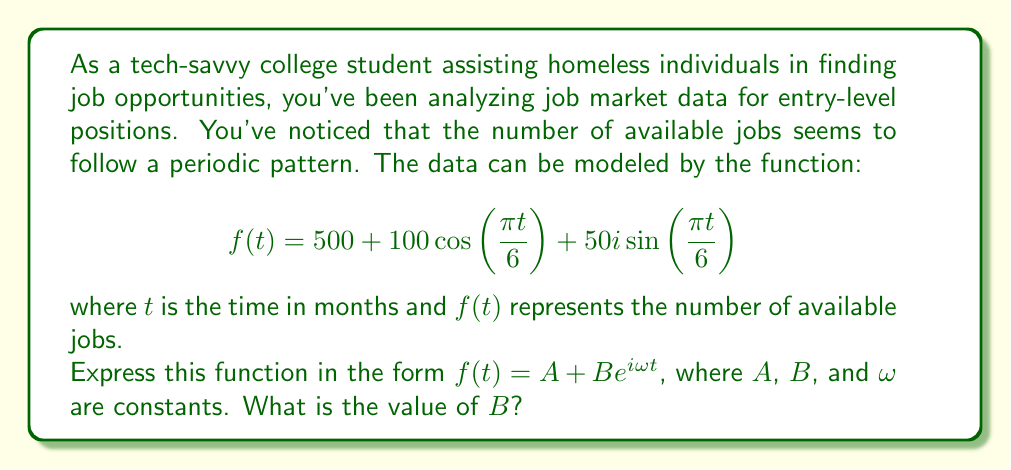Help me with this question. To express the given function in the form $f(t) = A + Be^{i\omega t}$, we need to follow these steps:

1) First, we identify that $A = 500$, as this is the constant term in the original function.

2) Next, we need to combine the cosine and sine terms into a complex exponential using Euler's formula:

   $e^{i\theta} = \cos\theta + i\sin\theta$

3) In our case, we have:

   $100\cos\left(\frac{\pi t}{6}\right) + 50i\sin\left(\frac{\pi t}{6}\right)$

4) We can factor out the common term:

   $100\left(\cos\left(\frac{\pi t}{6}\right) + \frac{1}{2}i\sin\left(\frac{\pi t}{6}\right)\right)$

5) Now, we need to find $B$ such that:

   $Be^{i\frac{\pi t}{6}} = 100\left(\cos\left(\frac{\pi t}{6}\right) + \frac{1}{2}i\sin\left(\frac{\pi t}{6}\right)\right)$

6) Comparing this with Euler's formula, we can see that:

   $B\left(\cos\left(\frac{\pi t}{6}\right) + i\sin\left(\frac{\pi t}{6}\right)\right) = 100\left(\cos\left(\frac{\pi t}{6}\right) + \frac{1}{2}i\sin\left(\frac{\pi t}{6}\right)\right)$

7) For this equality to hold, we must have:

   $B = 100\sqrt{1^2 + (\frac{1}{2})^2} = 100\sqrt{\frac{5}{4}} = 50\sqrt{5}$

8) We can also identify that $\omega = \frac{\pi}{6}$

Therefore, the function can be expressed as:

$$f(t) = 500 + 50\sqrt{5}e^{i\frac{\pi t}{6}}$$

And the value of $B$ is $50\sqrt{5}$.
Answer: $B = 50\sqrt{5}$ 